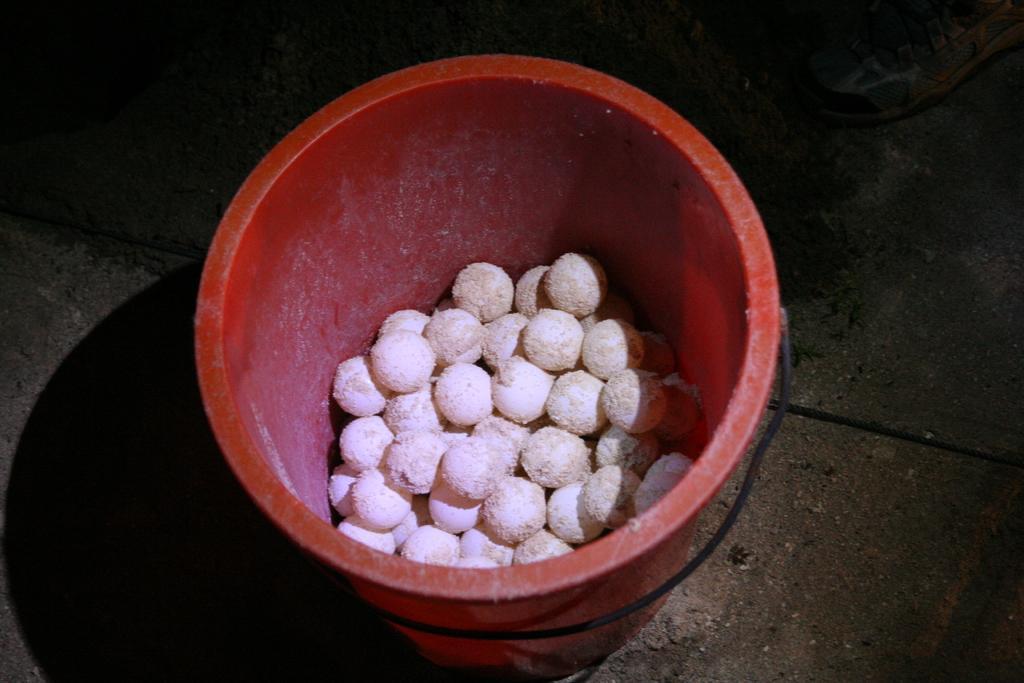Could you give a brief overview of what you see in this image? In the center of the image we can see the round white color food items in a red color dustbin which is on the road. 